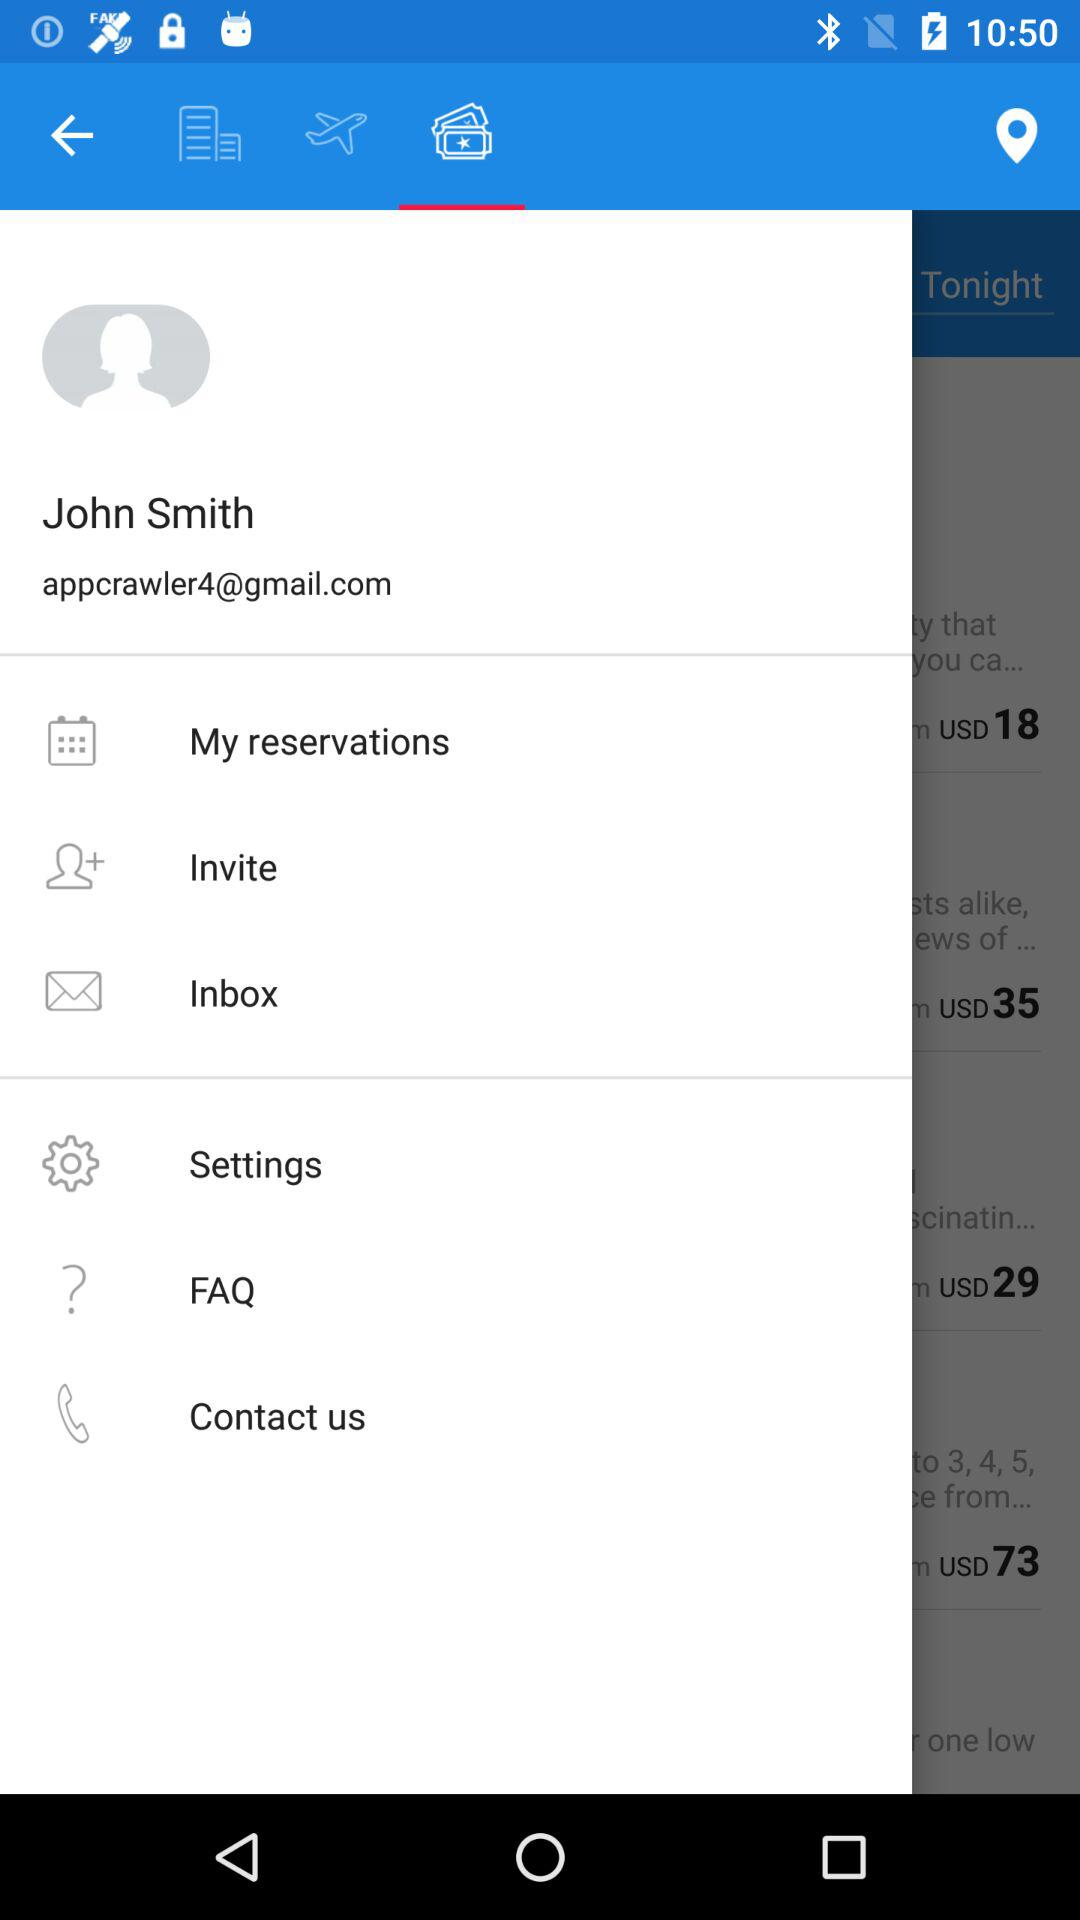What is the user name? The user name is John Smith. 